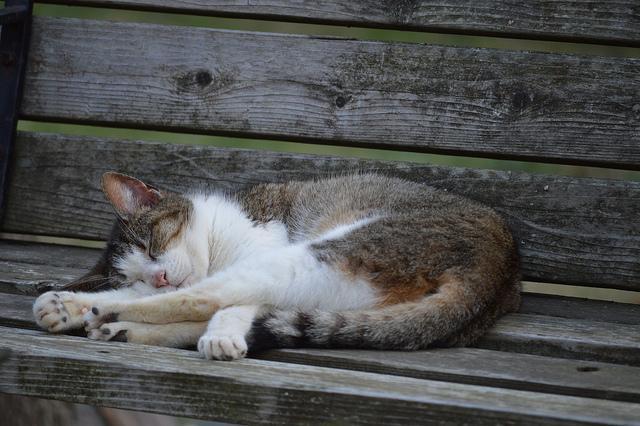How many forks are there?
Give a very brief answer. 0. 